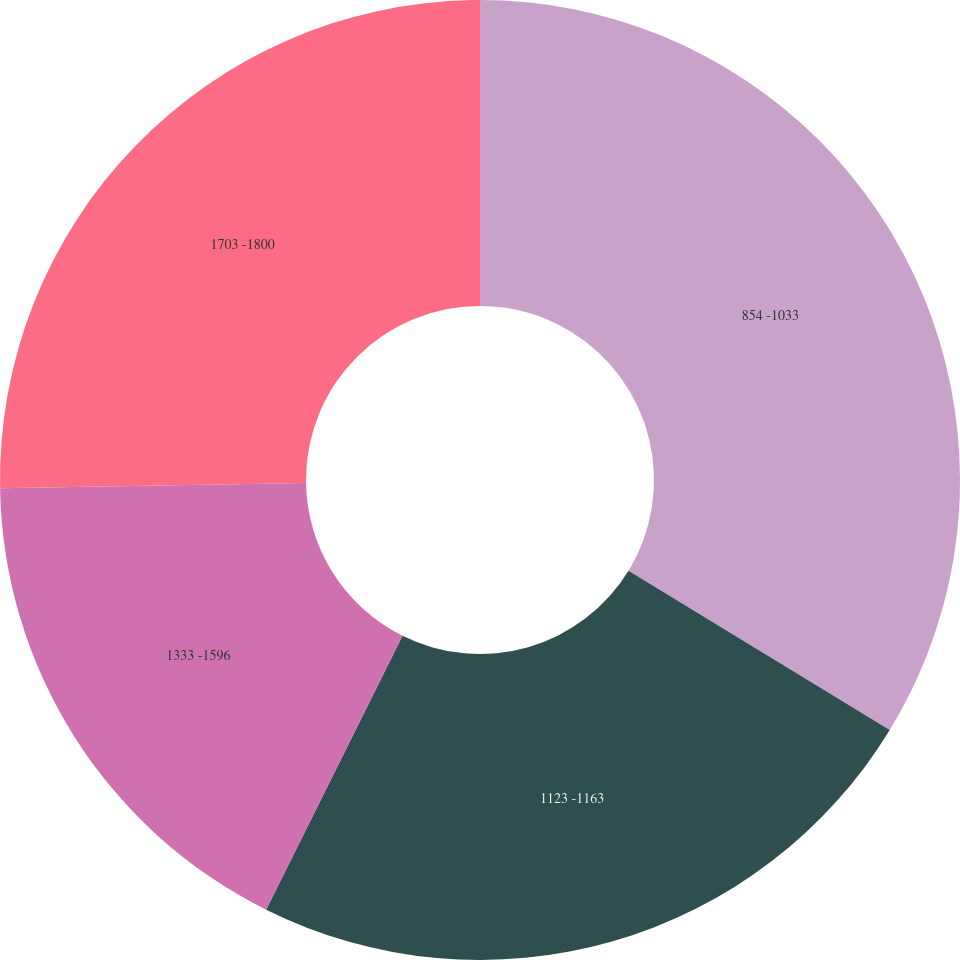Convert chart. <chart><loc_0><loc_0><loc_500><loc_500><pie_chart><fcel>854 -1033<fcel>1123 -1163<fcel>1333 -1596<fcel>1703 -1800<nl><fcel>33.72%<fcel>23.63%<fcel>17.38%<fcel>25.27%<nl></chart> 